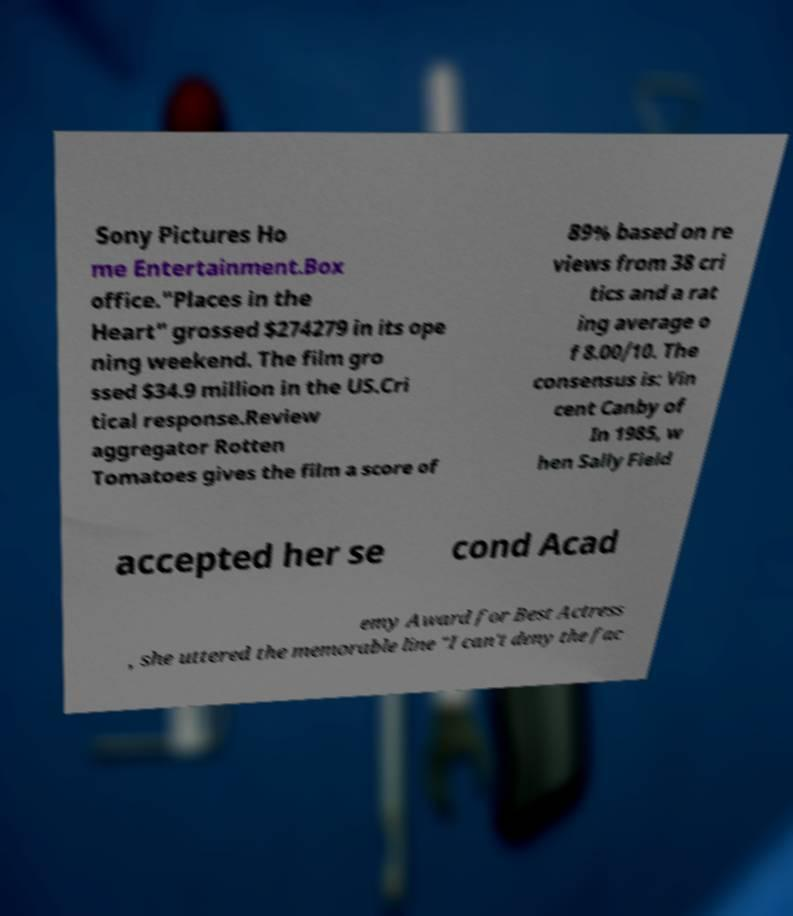Could you extract and type out the text from this image? Sony Pictures Ho me Entertainment.Box office."Places in the Heart" grossed $274279 in its ope ning weekend. The film gro ssed $34.9 million in the US.Cri tical response.Review aggregator Rotten Tomatoes gives the film a score of 89% based on re views from 38 cri tics and a rat ing average o f 8.00/10. The consensus is: Vin cent Canby of In 1985, w hen Sally Field accepted her se cond Acad emy Award for Best Actress , she uttered the memorable line "I can't deny the fac 